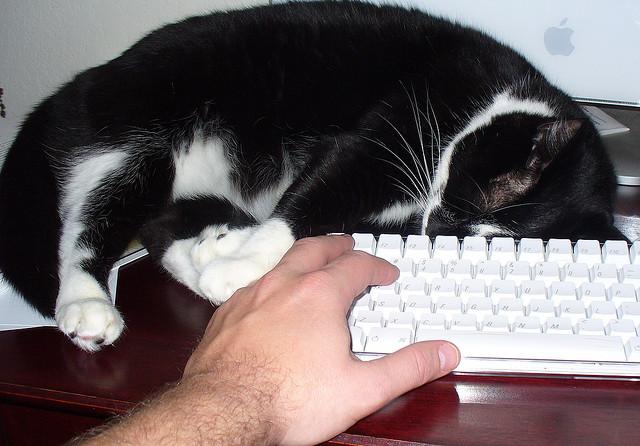Is the cat asleep?
Be succinct. Yes. What color is the cat?
Answer briefly. Black and white. Is the cat trying to get the person's attention?
Quick response, please. No. What color are the keys?
Concise answer only. White. 